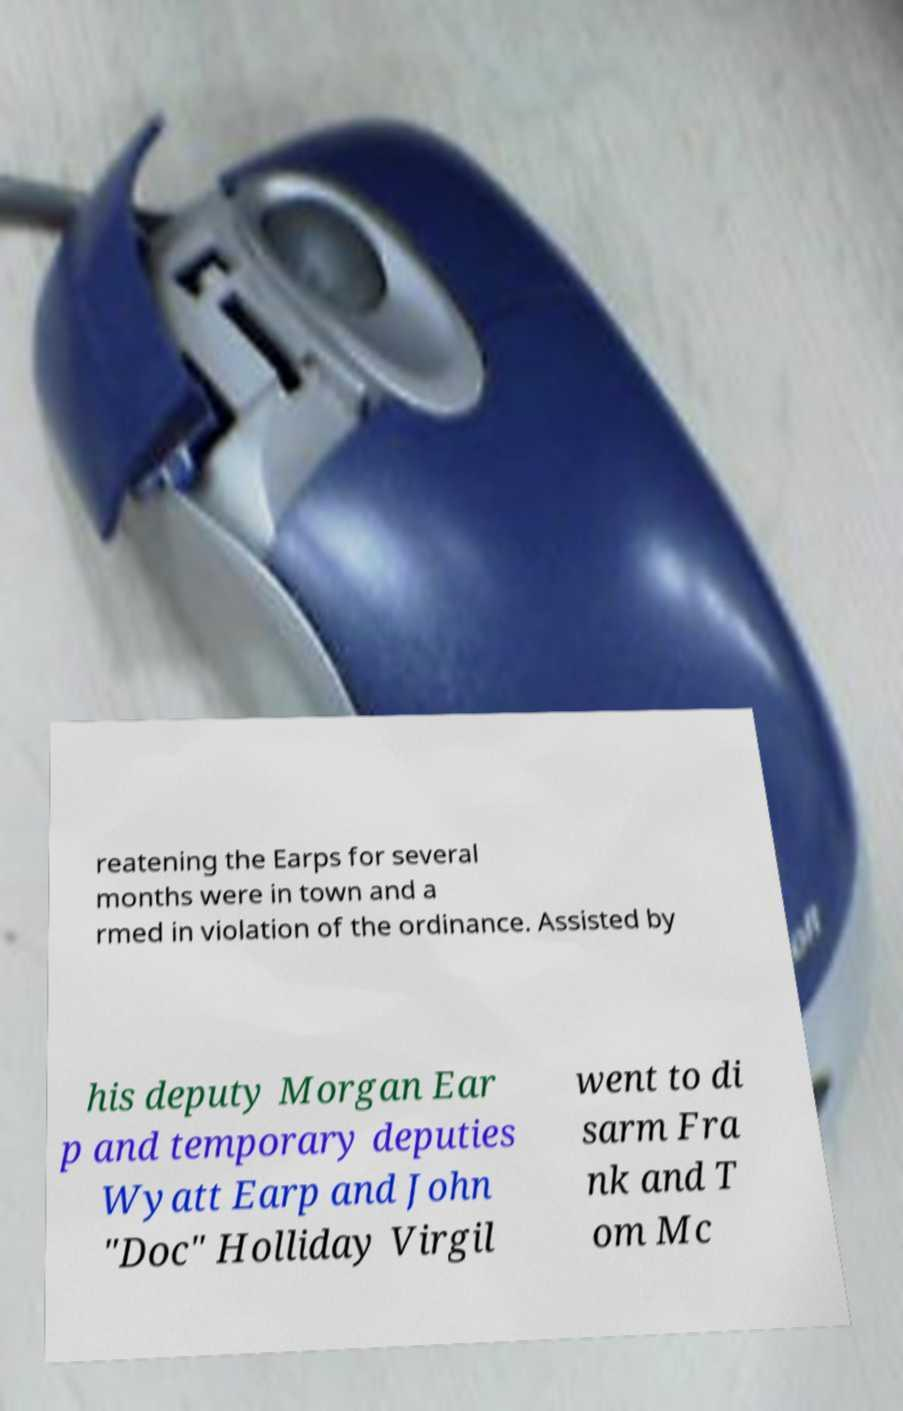There's text embedded in this image that I need extracted. Can you transcribe it verbatim? reatening the Earps for several months were in town and a rmed in violation of the ordinance. Assisted by his deputy Morgan Ear p and temporary deputies Wyatt Earp and John "Doc" Holliday Virgil went to di sarm Fra nk and T om Mc 